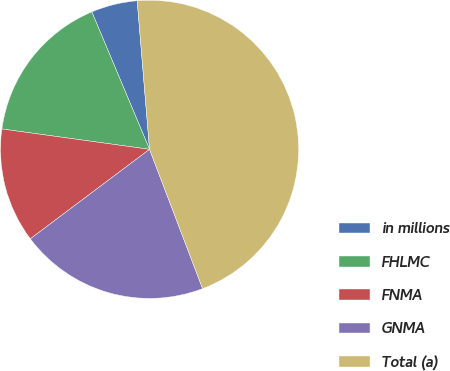Convert chart to OTSL. <chart><loc_0><loc_0><loc_500><loc_500><pie_chart><fcel>in millions<fcel>FHLMC<fcel>FNMA<fcel>GNMA<fcel>Total (a)<nl><fcel>5.01%<fcel>16.49%<fcel>12.43%<fcel>20.54%<fcel>45.53%<nl></chart> 